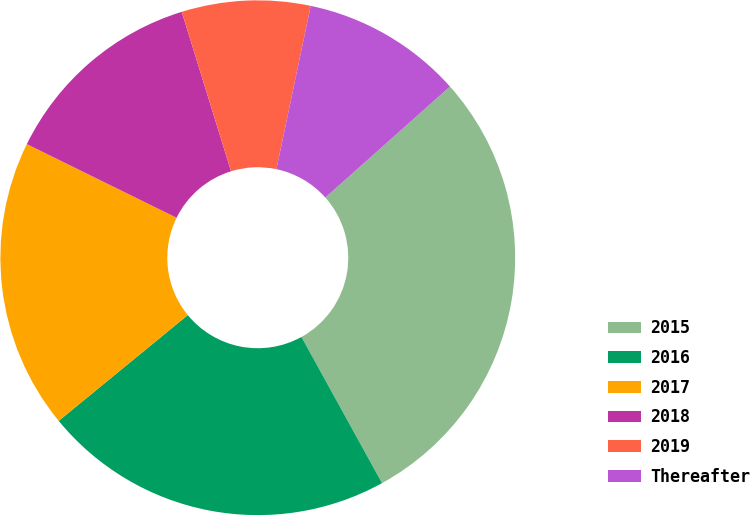Convert chart to OTSL. <chart><loc_0><loc_0><loc_500><loc_500><pie_chart><fcel>2015<fcel>2016<fcel>2017<fcel>2018<fcel>2019<fcel>Thereafter<nl><fcel>28.56%<fcel>22.09%<fcel>18.2%<fcel>12.95%<fcel>8.07%<fcel>10.12%<nl></chart> 